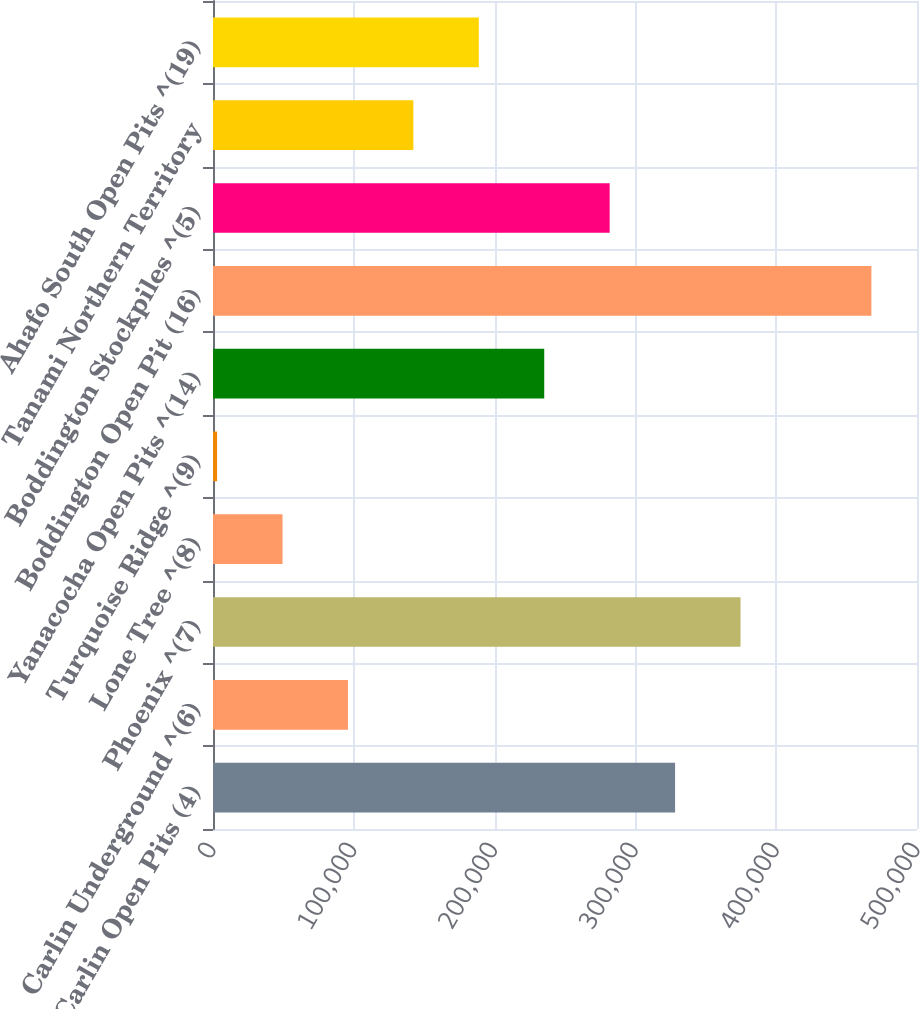<chart> <loc_0><loc_0><loc_500><loc_500><bar_chart><fcel>Carlin Open Pits (4)<fcel>Carlin Underground ^(6)<fcel>Phoenix ^(7)<fcel>Lone Tree ^(8)<fcel>Turquoise Ridge ^(9)<fcel>Yanacocha Open Pits ^(14)<fcel>Boddington Open Pit (16)<fcel>Boddington Stockpiles ^(5)<fcel>Tanami Northern Territory<fcel>Ahafo South Open Pits ^(19)<nl><fcel>328190<fcel>95840<fcel>374660<fcel>49370<fcel>2900<fcel>235250<fcel>467600<fcel>281720<fcel>142310<fcel>188780<nl></chart> 